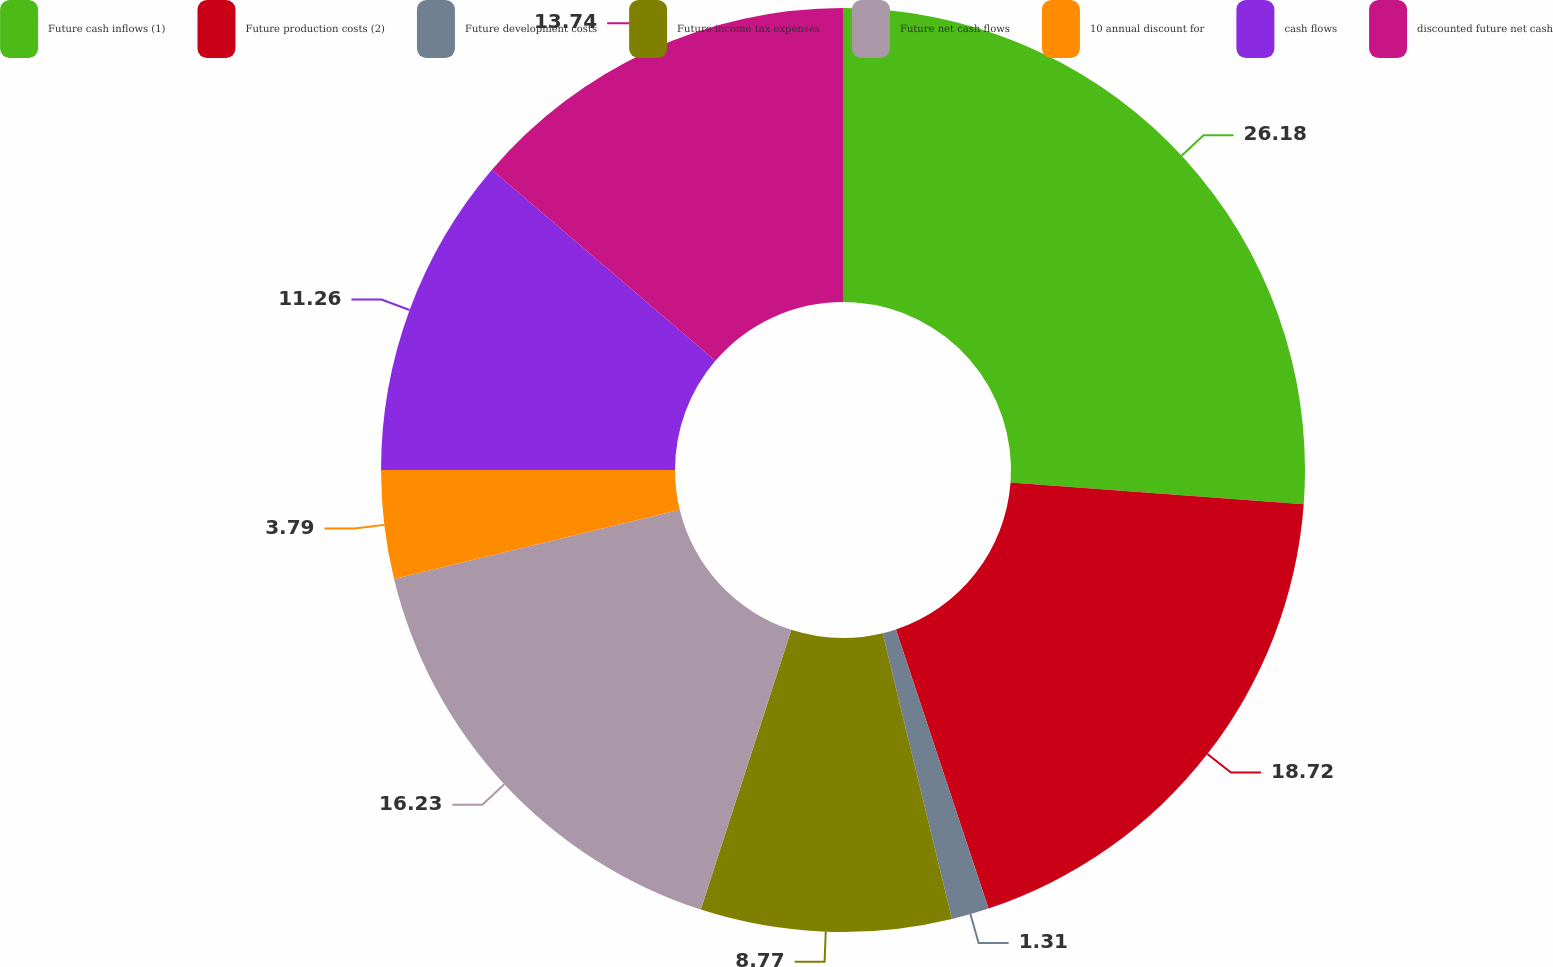Convert chart. <chart><loc_0><loc_0><loc_500><loc_500><pie_chart><fcel>Future cash inflows (1)<fcel>Future production costs (2)<fcel>Future development costs<fcel>Future income tax expenses<fcel>Future net cash flows<fcel>10 annual discount for<fcel>cash flows<fcel>discounted future net cash<nl><fcel>26.18%<fcel>18.72%<fcel>1.31%<fcel>8.77%<fcel>16.23%<fcel>3.79%<fcel>11.26%<fcel>13.74%<nl></chart> 